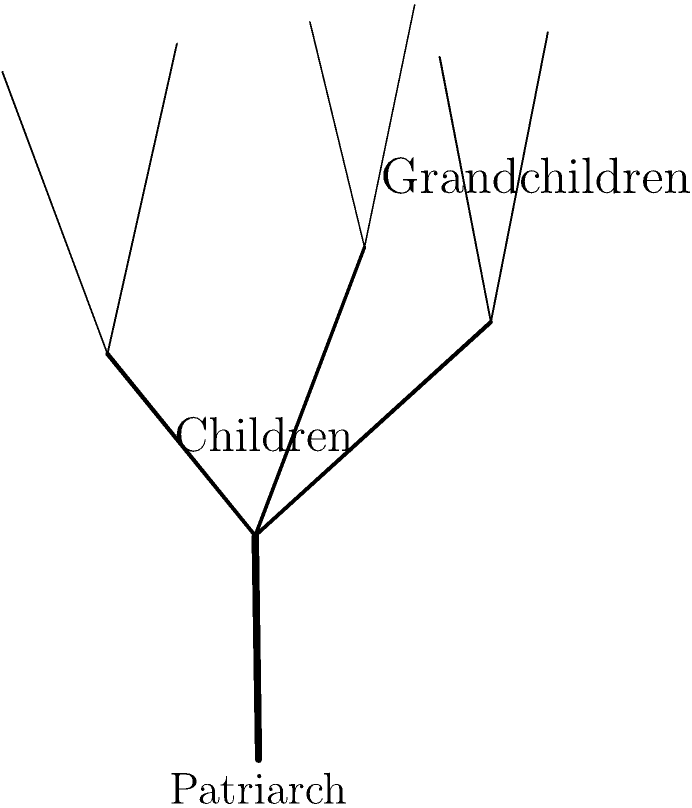In this visualization of a traditional family tree, how many direct descendants (children and grandchildren) does the patriarch have in total? To determine the total number of direct descendants, we need to count the children and grandchildren of the patriarch:

1. Children (second generation):
   - Count the branches stemming directly from the trunk.
   - There are 3 branches, representing 3 children.

2. Grandchildren (third generation):
   - Count the leaves at the end of each branch.
   - Left branch: 2 leaves
   - Middle branch: 2 leaves
   - Right branch: 2 leaves
   - Total grandchildren: 2 + 2 + 2 = 6

3. Total direct descendants:
   - Sum of children and grandchildren
   - Children + Grandchildren = 3 + 6 = 9

Therefore, the patriarch has a total of 9 direct descendants.
Answer: 9 